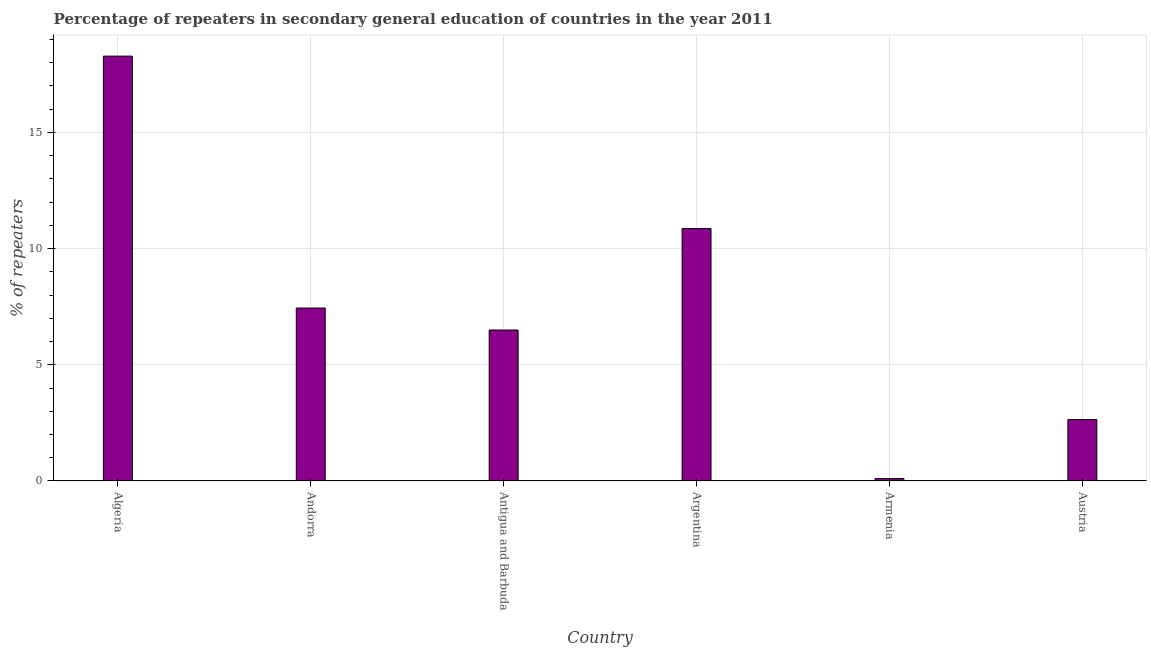Does the graph contain any zero values?
Your answer should be compact. No. Does the graph contain grids?
Your answer should be very brief. Yes. What is the title of the graph?
Offer a very short reply. Percentage of repeaters in secondary general education of countries in the year 2011. What is the label or title of the Y-axis?
Offer a terse response. % of repeaters. What is the percentage of repeaters in Argentina?
Your answer should be very brief. 10.86. Across all countries, what is the maximum percentage of repeaters?
Your answer should be compact. 18.28. Across all countries, what is the minimum percentage of repeaters?
Make the answer very short. 0.1. In which country was the percentage of repeaters maximum?
Offer a very short reply. Algeria. In which country was the percentage of repeaters minimum?
Make the answer very short. Armenia. What is the sum of the percentage of repeaters?
Provide a succinct answer. 45.83. What is the difference between the percentage of repeaters in Antigua and Barbuda and Argentina?
Give a very brief answer. -4.37. What is the average percentage of repeaters per country?
Offer a very short reply. 7.64. What is the median percentage of repeaters?
Keep it short and to the point. 6.97. What is the ratio of the percentage of repeaters in Andorra to that in Antigua and Barbuda?
Offer a very short reply. 1.15. What is the difference between the highest and the second highest percentage of repeaters?
Offer a very short reply. 7.42. What is the difference between the highest and the lowest percentage of repeaters?
Your answer should be compact. 18.18. How many bars are there?
Provide a short and direct response. 6. Are all the bars in the graph horizontal?
Offer a very short reply. No. Are the values on the major ticks of Y-axis written in scientific E-notation?
Ensure brevity in your answer.  No. What is the % of repeaters of Algeria?
Offer a terse response. 18.28. What is the % of repeaters of Andorra?
Give a very brief answer. 7.44. What is the % of repeaters of Antigua and Barbuda?
Your answer should be compact. 6.5. What is the % of repeaters in Argentina?
Provide a short and direct response. 10.86. What is the % of repeaters in Armenia?
Make the answer very short. 0.1. What is the % of repeaters in Austria?
Ensure brevity in your answer.  2.64. What is the difference between the % of repeaters in Algeria and Andorra?
Make the answer very short. 10.84. What is the difference between the % of repeaters in Algeria and Antigua and Barbuda?
Your answer should be very brief. 11.79. What is the difference between the % of repeaters in Algeria and Argentina?
Your answer should be very brief. 7.42. What is the difference between the % of repeaters in Algeria and Armenia?
Keep it short and to the point. 18.18. What is the difference between the % of repeaters in Algeria and Austria?
Your answer should be very brief. 15.64. What is the difference between the % of repeaters in Andorra and Antigua and Barbuda?
Provide a short and direct response. 0.95. What is the difference between the % of repeaters in Andorra and Argentina?
Ensure brevity in your answer.  -3.42. What is the difference between the % of repeaters in Andorra and Armenia?
Give a very brief answer. 7.34. What is the difference between the % of repeaters in Andorra and Austria?
Offer a very short reply. 4.8. What is the difference between the % of repeaters in Antigua and Barbuda and Argentina?
Your response must be concise. -4.37. What is the difference between the % of repeaters in Antigua and Barbuda and Armenia?
Offer a very short reply. 6.39. What is the difference between the % of repeaters in Antigua and Barbuda and Austria?
Provide a short and direct response. 3.85. What is the difference between the % of repeaters in Argentina and Armenia?
Your response must be concise. 10.76. What is the difference between the % of repeaters in Argentina and Austria?
Keep it short and to the point. 8.22. What is the difference between the % of repeaters in Armenia and Austria?
Your answer should be very brief. -2.54. What is the ratio of the % of repeaters in Algeria to that in Andorra?
Make the answer very short. 2.46. What is the ratio of the % of repeaters in Algeria to that in Antigua and Barbuda?
Make the answer very short. 2.81. What is the ratio of the % of repeaters in Algeria to that in Argentina?
Ensure brevity in your answer.  1.68. What is the ratio of the % of repeaters in Algeria to that in Armenia?
Your answer should be compact. 175.23. What is the ratio of the % of repeaters in Algeria to that in Austria?
Provide a short and direct response. 6.92. What is the ratio of the % of repeaters in Andorra to that in Antigua and Barbuda?
Provide a short and direct response. 1.15. What is the ratio of the % of repeaters in Andorra to that in Argentina?
Provide a succinct answer. 0.69. What is the ratio of the % of repeaters in Andorra to that in Armenia?
Your answer should be compact. 71.33. What is the ratio of the % of repeaters in Andorra to that in Austria?
Provide a succinct answer. 2.82. What is the ratio of the % of repeaters in Antigua and Barbuda to that in Argentina?
Give a very brief answer. 0.6. What is the ratio of the % of repeaters in Antigua and Barbuda to that in Armenia?
Provide a succinct answer. 62.27. What is the ratio of the % of repeaters in Antigua and Barbuda to that in Austria?
Provide a short and direct response. 2.46. What is the ratio of the % of repeaters in Argentina to that in Armenia?
Your response must be concise. 104.12. What is the ratio of the % of repeaters in Argentina to that in Austria?
Provide a succinct answer. 4.11. What is the ratio of the % of repeaters in Armenia to that in Austria?
Offer a very short reply. 0.04. 